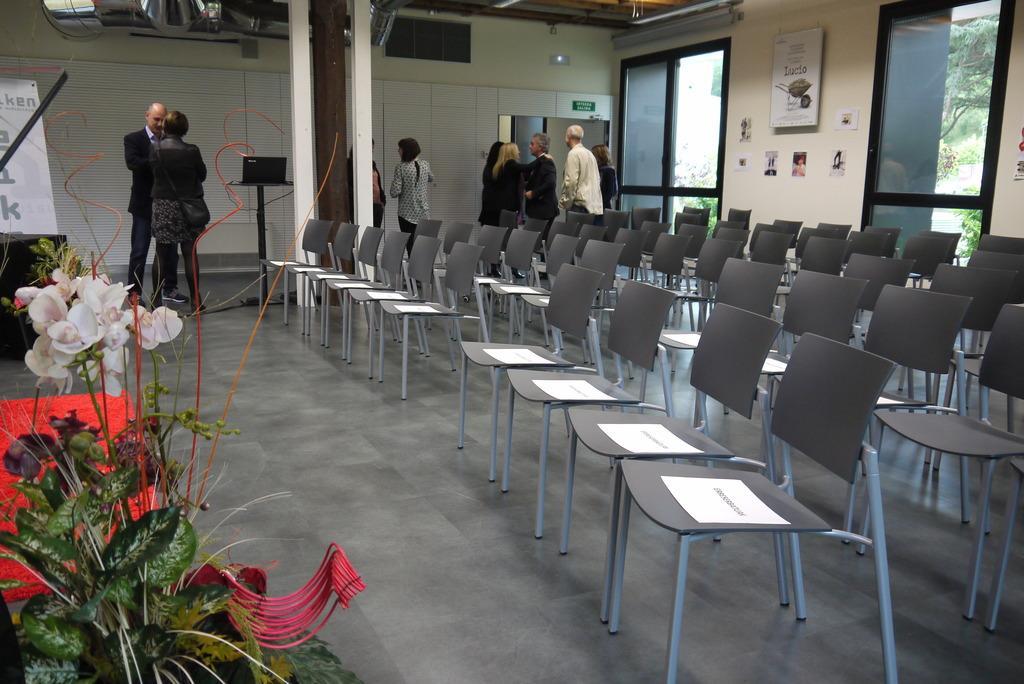Can you describe this image briefly? In this image I can see few people and number of chairs. Here I can see flower. Here I can see glass doors near this wall. 